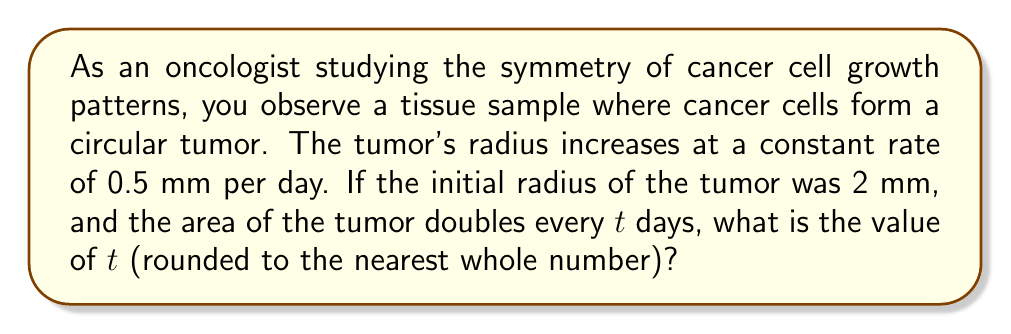Help me with this question. Let's approach this step-by-step:

1) The area of a circle is given by $A = \pi r^2$, where $r$ is the radius.

2) The initial area of the tumor is:
   $A_0 = \pi (2 \text{ mm})^2 = 4\pi \text{ mm}^2$

3) After $t$ days, the radius will be:
   $r = 2 + 0.5t \text{ mm}$

4) The area after $t$ days is:
   $A_t = \pi (2 + 0.5t)^2 \text{ mm}^2$

5) We're told that the area doubles after $t$ days, so:
   $A_t = 2A_0$

6) We can write this as an equation:
   $\pi (2 + 0.5t)^2 = 2(4\pi)$

7) Simplify:
   $(2 + 0.5t)^2 = 8$

8) Take the square root of both sides:
   $2 + 0.5t = \sqrt{8} = 2\sqrt{2}$

9) Subtract 2 from both sides:
   $0.5t = 2\sqrt{2} - 2$

10) Multiply both sides by 2:
    $t = 2(2\sqrt{2} - 2) = 4\sqrt{2} - 4$

11) Calculate the value:
    $t \approx 5.66$

12) Rounding to the nearest whole number:
    $t \approx 6$
Answer: $t = 6$ days 